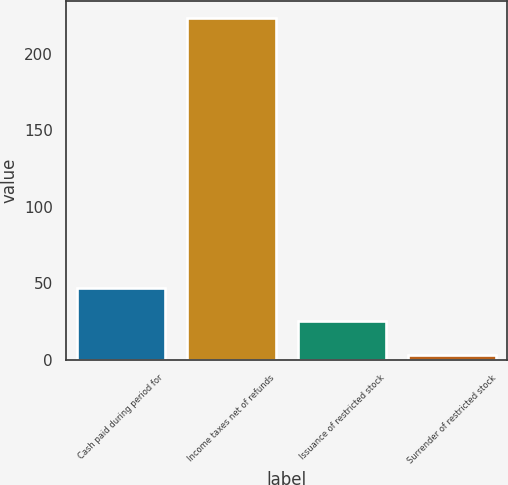<chart> <loc_0><loc_0><loc_500><loc_500><bar_chart><fcel>Cash paid during period for<fcel>Income taxes net of refunds<fcel>Issuance of restricted stock<fcel>Surrender of restricted stock<nl><fcel>47.12<fcel>223.2<fcel>25.11<fcel>3.1<nl></chart> 